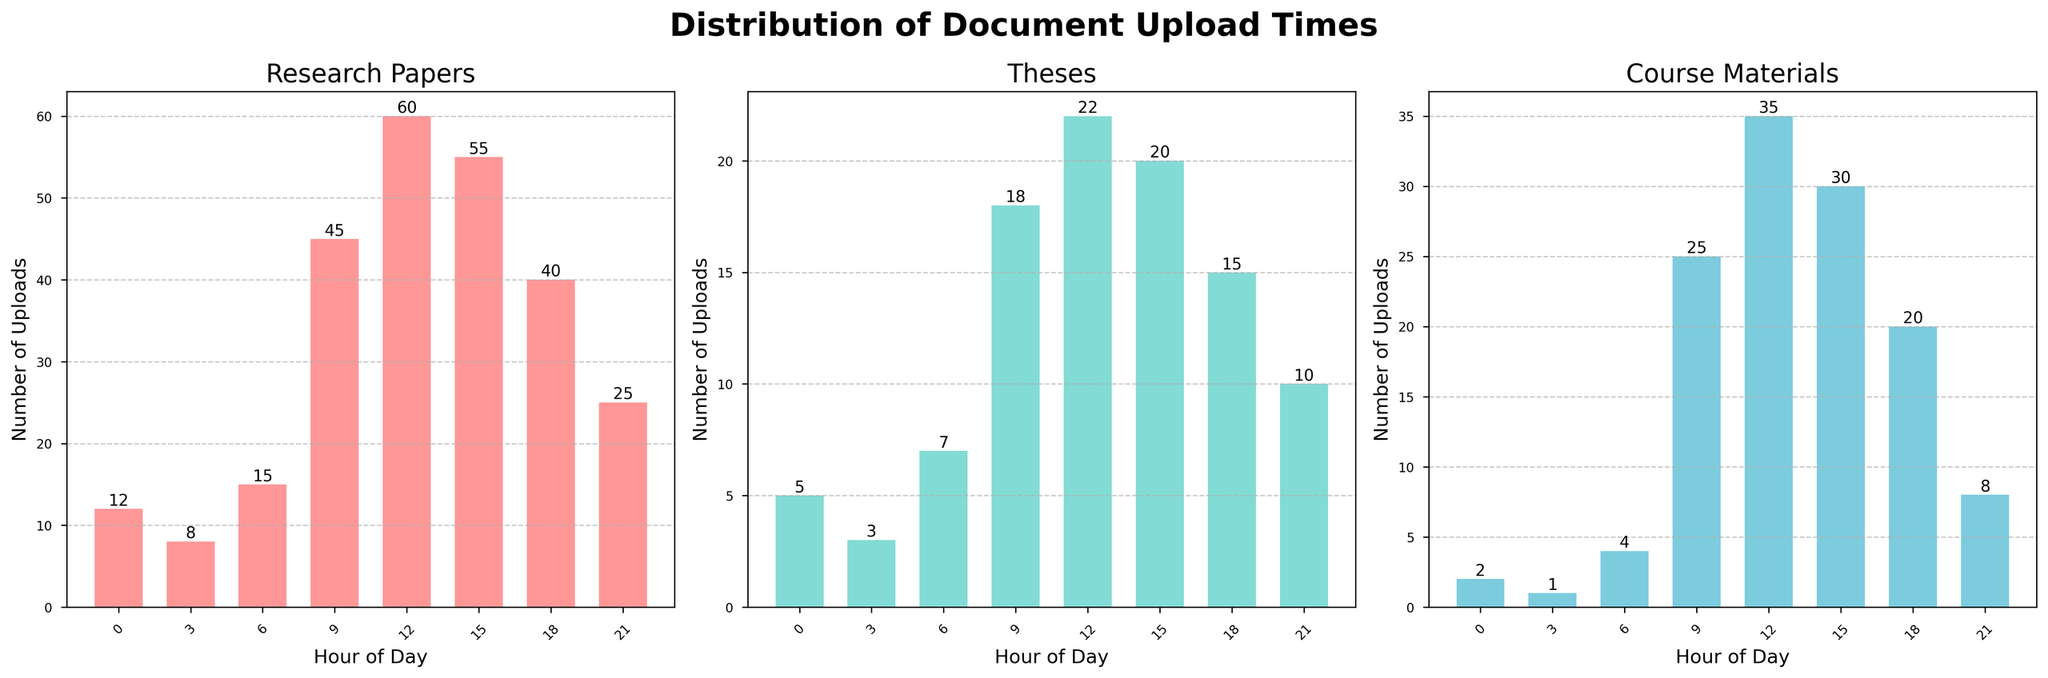What is the title of the figure? The title usually appears at the top of the figure. In this case, it's "Distribution of Document Upload Times".
Answer: Distribution of Document Upload Times How many subplots (individual histograms) are displayed? There are three subplots, indicated by the figure having three bars for each time slot across categories.
Answer: 3 Which document category has the highest number of uploads at 12 PM? Check the bar height at 12 PM for each category: Research Papers, Theses, and Course Materials. The tallest bar represents Research Papers with 60 uploads.
Answer: Research Papers What is the overall trend for uploads of Theses across the day? Observe the peaks and troughs in the Theses subplot. It starts low, increases at 9 AM, peaks at 12 PM, and then decreases through the afternoon and evening.
Answer: Peaks at 12 PM, decreases afterwards What time of day has the least uploads for Course Materials? Find the shortest bar in the Course Materials subplot. The smallest value is at 3 AM with only 1 upload.
Answer: 3 AM Which time slot shows the most uploads for Research Papers? Look at the highest bar in the Research Papers subplot. The 12 PM slot has the highest number of uploads at 60.
Answer: 12 PM At 9 AM, how many more uploads are there for Course Materials compared to Theses? The number of uploads for Course Materials at 9 AM is 25, and for Theses is 18. Subtract to find the difference: 25 - 18 = 7.
Answer: 7 Compare the upload patterns between Research Papers and Course Materials. Which category shows more uploads in the afternoon (12 PM to 6 PM)? Add the upload counts for these categories from 12 PM and 3 PM. Research Papers: 60 + 55 = 115, Course Materials: 35 + 30 = 65.
Answer: Research Papers What is the sum of uploads for all categories at 6 AM? Sum the values at 6 AM from all subplots: Research Papers (15) + Theses (7) + Course Materials (4). The total sum is 15 + 7 + 4 = 26.
Answer: 26 How do uploads of Theses change from 0 AM to 3 AM? Compare the values at 0 AM (5 uploads) and 3 AM (3 uploads). The number decreases by 2.
Answer: Decreased by 2 